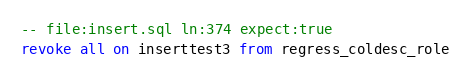<code> <loc_0><loc_0><loc_500><loc_500><_SQL_>-- file:insert.sql ln:374 expect:true
revoke all on inserttest3 from regress_coldesc_role
</code> 